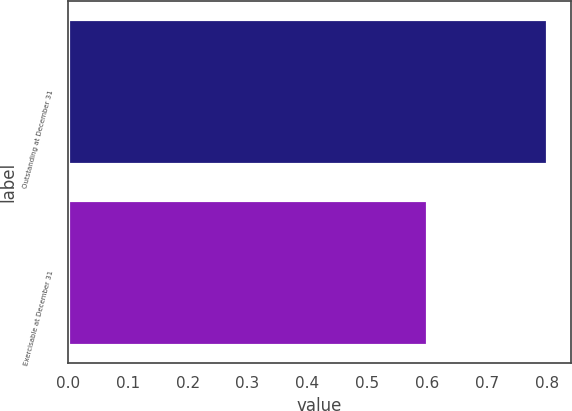Convert chart. <chart><loc_0><loc_0><loc_500><loc_500><bar_chart><fcel>Outstanding at December 31<fcel>Exercisable at December 31<nl><fcel>0.8<fcel>0.6<nl></chart> 